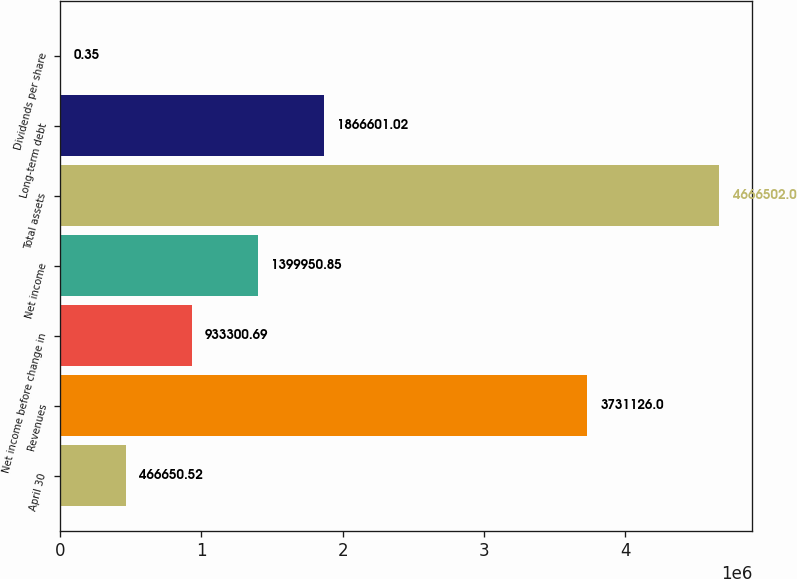Convert chart to OTSL. <chart><loc_0><loc_0><loc_500><loc_500><bar_chart><fcel>April 30<fcel>Revenues<fcel>Net income before change in<fcel>Net income<fcel>Total assets<fcel>Long-term debt<fcel>Dividends per share<nl><fcel>466651<fcel>3.73113e+06<fcel>933301<fcel>1.39995e+06<fcel>4.6665e+06<fcel>1.8666e+06<fcel>0.35<nl></chart> 